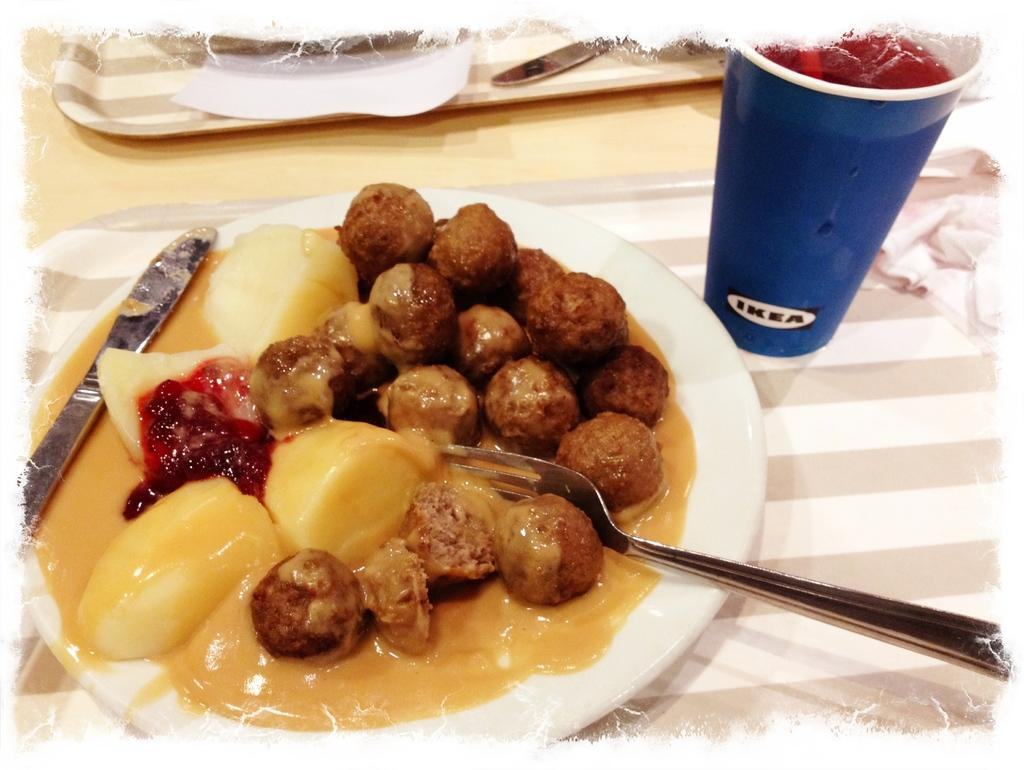What is the main piece of furniture in the image? There is a table in the image. What is placed on the table that is not typically found on a table? There are trees on the table. What items are present on the table for cleaning or wiping? Tissues are present on the table. What utensils can be seen on the table? Knives and forks are visible on the table. What type of beverage is on the table? There is a drink on the table. What type of food is on the table? Food items are on the table. What is the color of the border surrounding the image? The image has a white border. Can you hear the house laughing in the image? There is no house or laughter present in the image. 